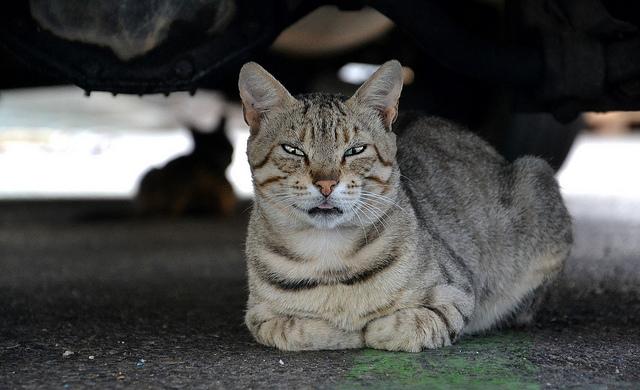Is there a bird feeder in the place?
Answer briefly. No. What is the cat underneath?
Be succinct. Car. What do you think the cat is looking at?
Write a very short answer. Camera. What is the cat sitting on?
Quick response, please. Ground. Which cat is closer to the camera?
Answer briefly. Gray. Where is the cat sitting?
Be succinct. Under car. How many cats are there?
Quick response, please. 2. Could the cat be under a vehicle?
Be succinct. Yes. How cute is this cat?
Short answer required. Very. 